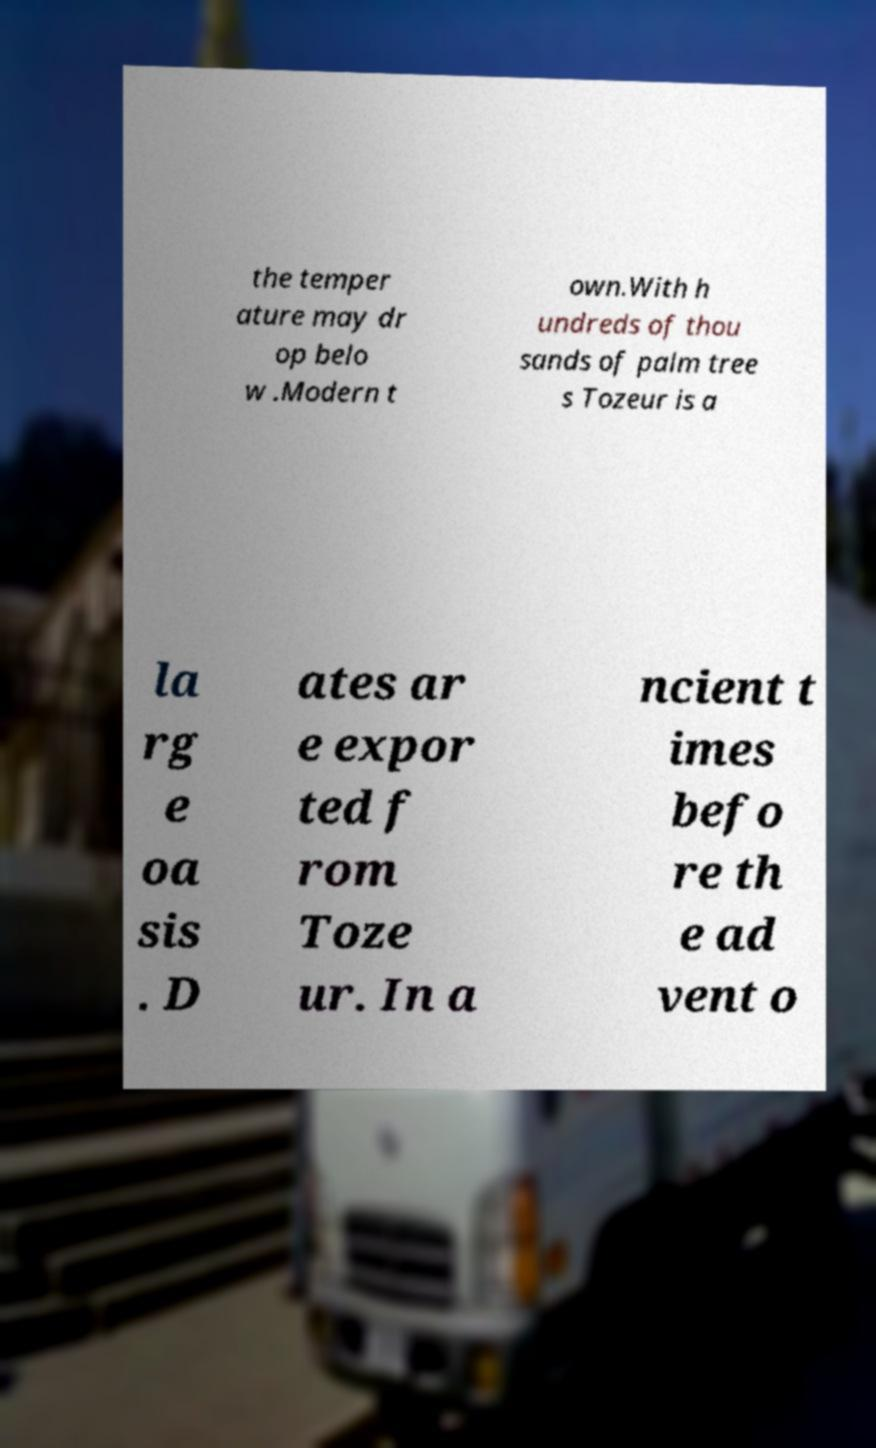Can you accurately transcribe the text from the provided image for me? the temper ature may dr op belo w .Modern t own.With h undreds of thou sands of palm tree s Tozeur is a la rg e oa sis . D ates ar e expor ted f rom Toze ur. In a ncient t imes befo re th e ad vent o 